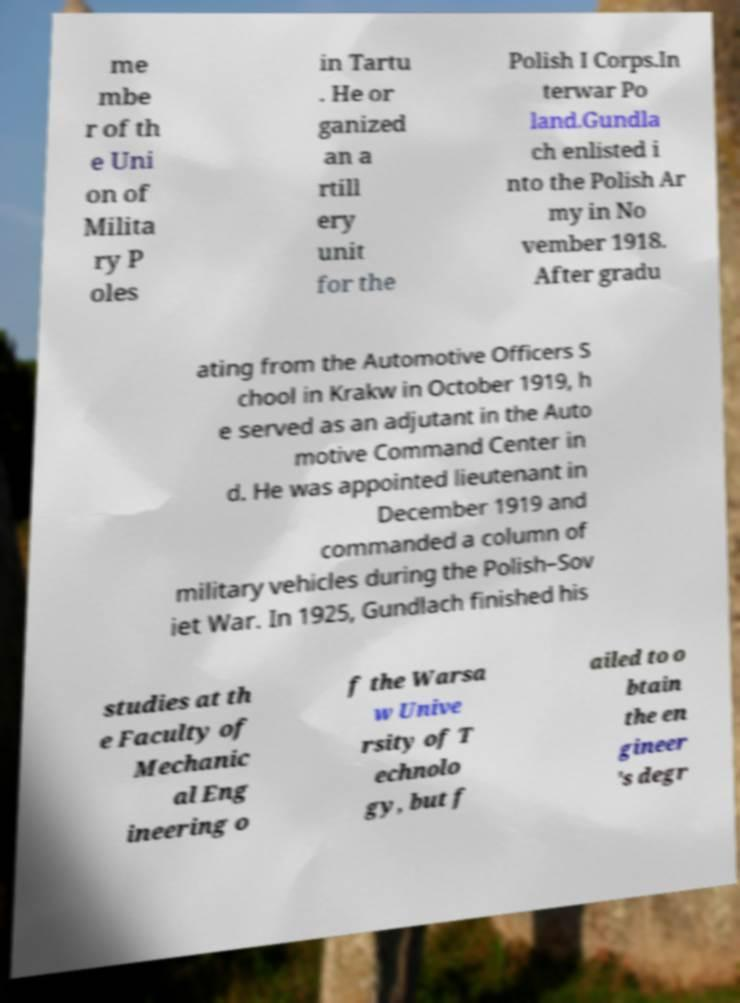I need the written content from this picture converted into text. Can you do that? me mbe r of th e Uni on of Milita ry P oles in Tartu . He or ganized an a rtill ery unit for the Polish I Corps.In terwar Po land.Gundla ch enlisted i nto the Polish Ar my in No vember 1918. After gradu ating from the Automotive Officers S chool in Krakw in October 1919, h e served as an adjutant in the Auto motive Command Center in d. He was appointed lieutenant in December 1919 and commanded a column of military vehicles during the Polish–Sov iet War. In 1925, Gundlach finished his studies at th e Faculty of Mechanic al Eng ineering o f the Warsa w Unive rsity of T echnolo gy, but f ailed to o btain the en gineer 's degr 